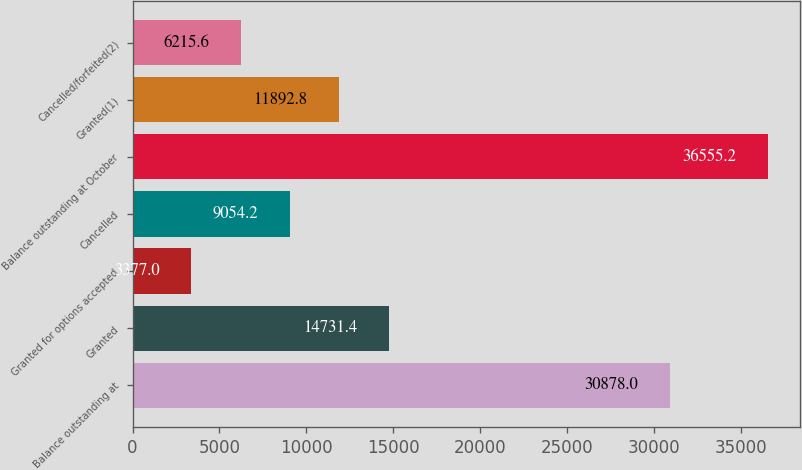Convert chart. <chart><loc_0><loc_0><loc_500><loc_500><bar_chart><fcel>Balance outstanding at<fcel>Granted<fcel>Granted for options accepted<fcel>Cancelled<fcel>Balance outstanding at October<fcel>Granted(1)<fcel>Cancelled/forfeited(2)<nl><fcel>30878<fcel>14731.4<fcel>3377<fcel>9054.2<fcel>36555.2<fcel>11892.8<fcel>6215.6<nl></chart> 